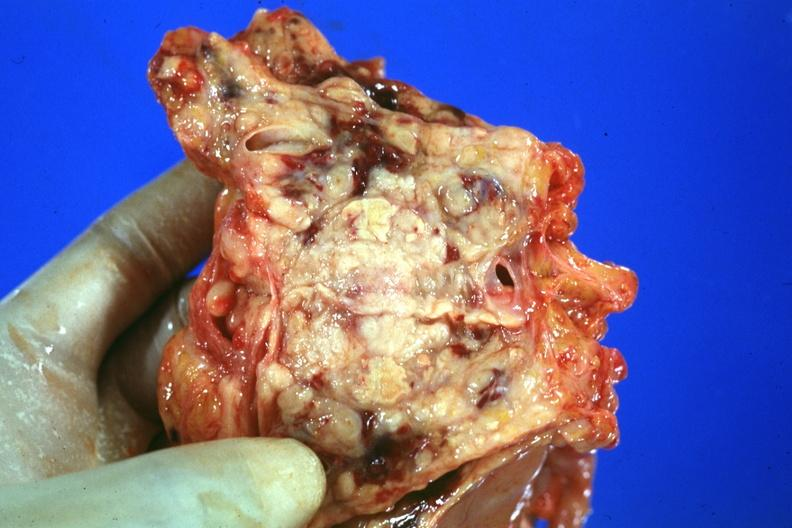what is present?
Answer the question using a single word or phrase. Adenocarcinoma 